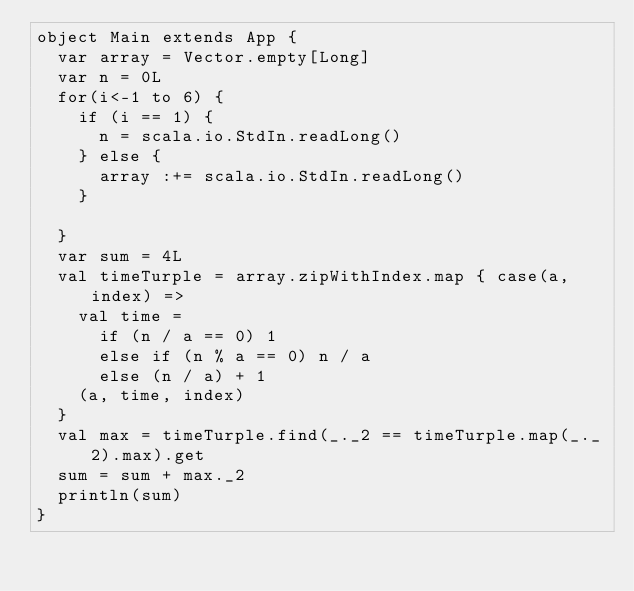Convert code to text. <code><loc_0><loc_0><loc_500><loc_500><_Scala_>object Main extends App {
  var array = Vector.empty[Long]
  var n = 0L
  for(i<-1 to 6) {
    if (i == 1) {
      n = scala.io.StdIn.readLong()
    } else {
      array :+= scala.io.StdIn.readLong()
    }

  }
  var sum = 4L
  val timeTurple = array.zipWithIndex.map { case(a, index) =>
    val time =
      if (n / a == 0) 1
      else if (n % a == 0) n / a
      else (n / a) + 1
    (a, time, index)
  }
  val max = timeTurple.find(_._2 == timeTurple.map(_._2).max).get
  sum = sum + max._2
  println(sum)
}</code> 